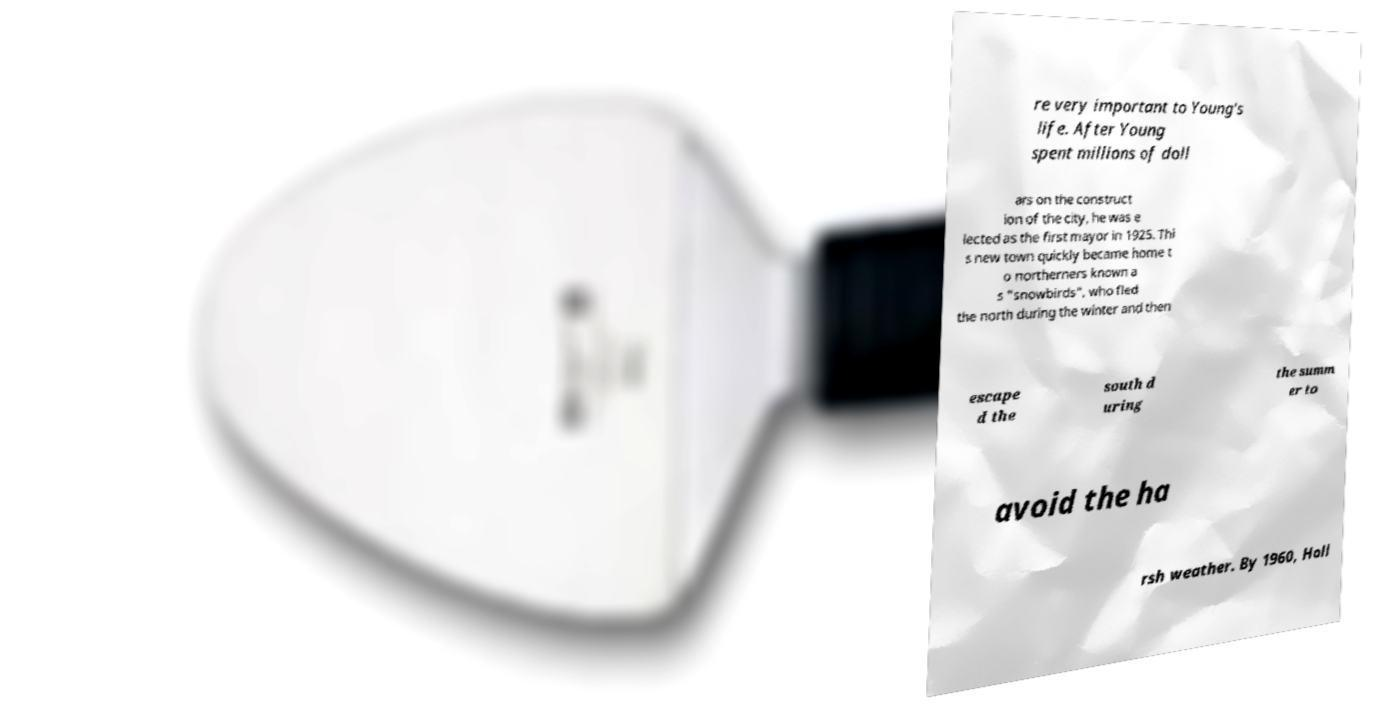Please identify and transcribe the text found in this image. re very important to Young's life. After Young spent millions of doll ars on the construct ion of the city, he was e lected as the first mayor in 1925. Thi s new town quickly became home t o northerners known a s "snowbirds", who fled the north during the winter and then escape d the south d uring the summ er to avoid the ha rsh weather. By 1960, Holl 